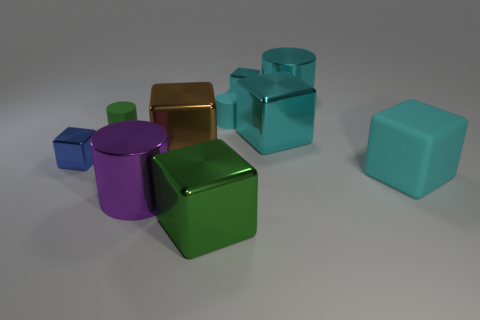Subtract all big cyan metallic cylinders. How many cylinders are left? 3 Subtract all cylinders. How many objects are left? 6 Subtract all brown cubes. How many cubes are left? 5 Subtract all cyan blocks. Subtract all metal cubes. How many objects are left? 2 Add 4 purple cylinders. How many purple cylinders are left? 5 Add 6 large yellow rubber balls. How many large yellow rubber balls exist? 6 Subtract 0 purple balls. How many objects are left? 10 Subtract 1 cylinders. How many cylinders are left? 3 Subtract all brown cylinders. Subtract all blue blocks. How many cylinders are left? 4 Subtract all cyan cylinders. How many blue blocks are left? 1 